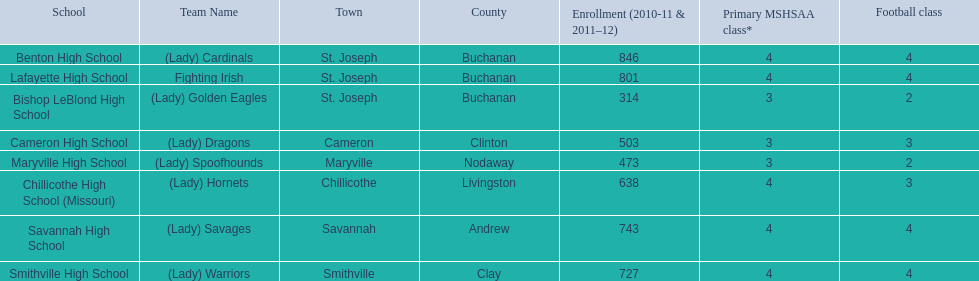What is the number of football classes lafayette high school has? 4. 